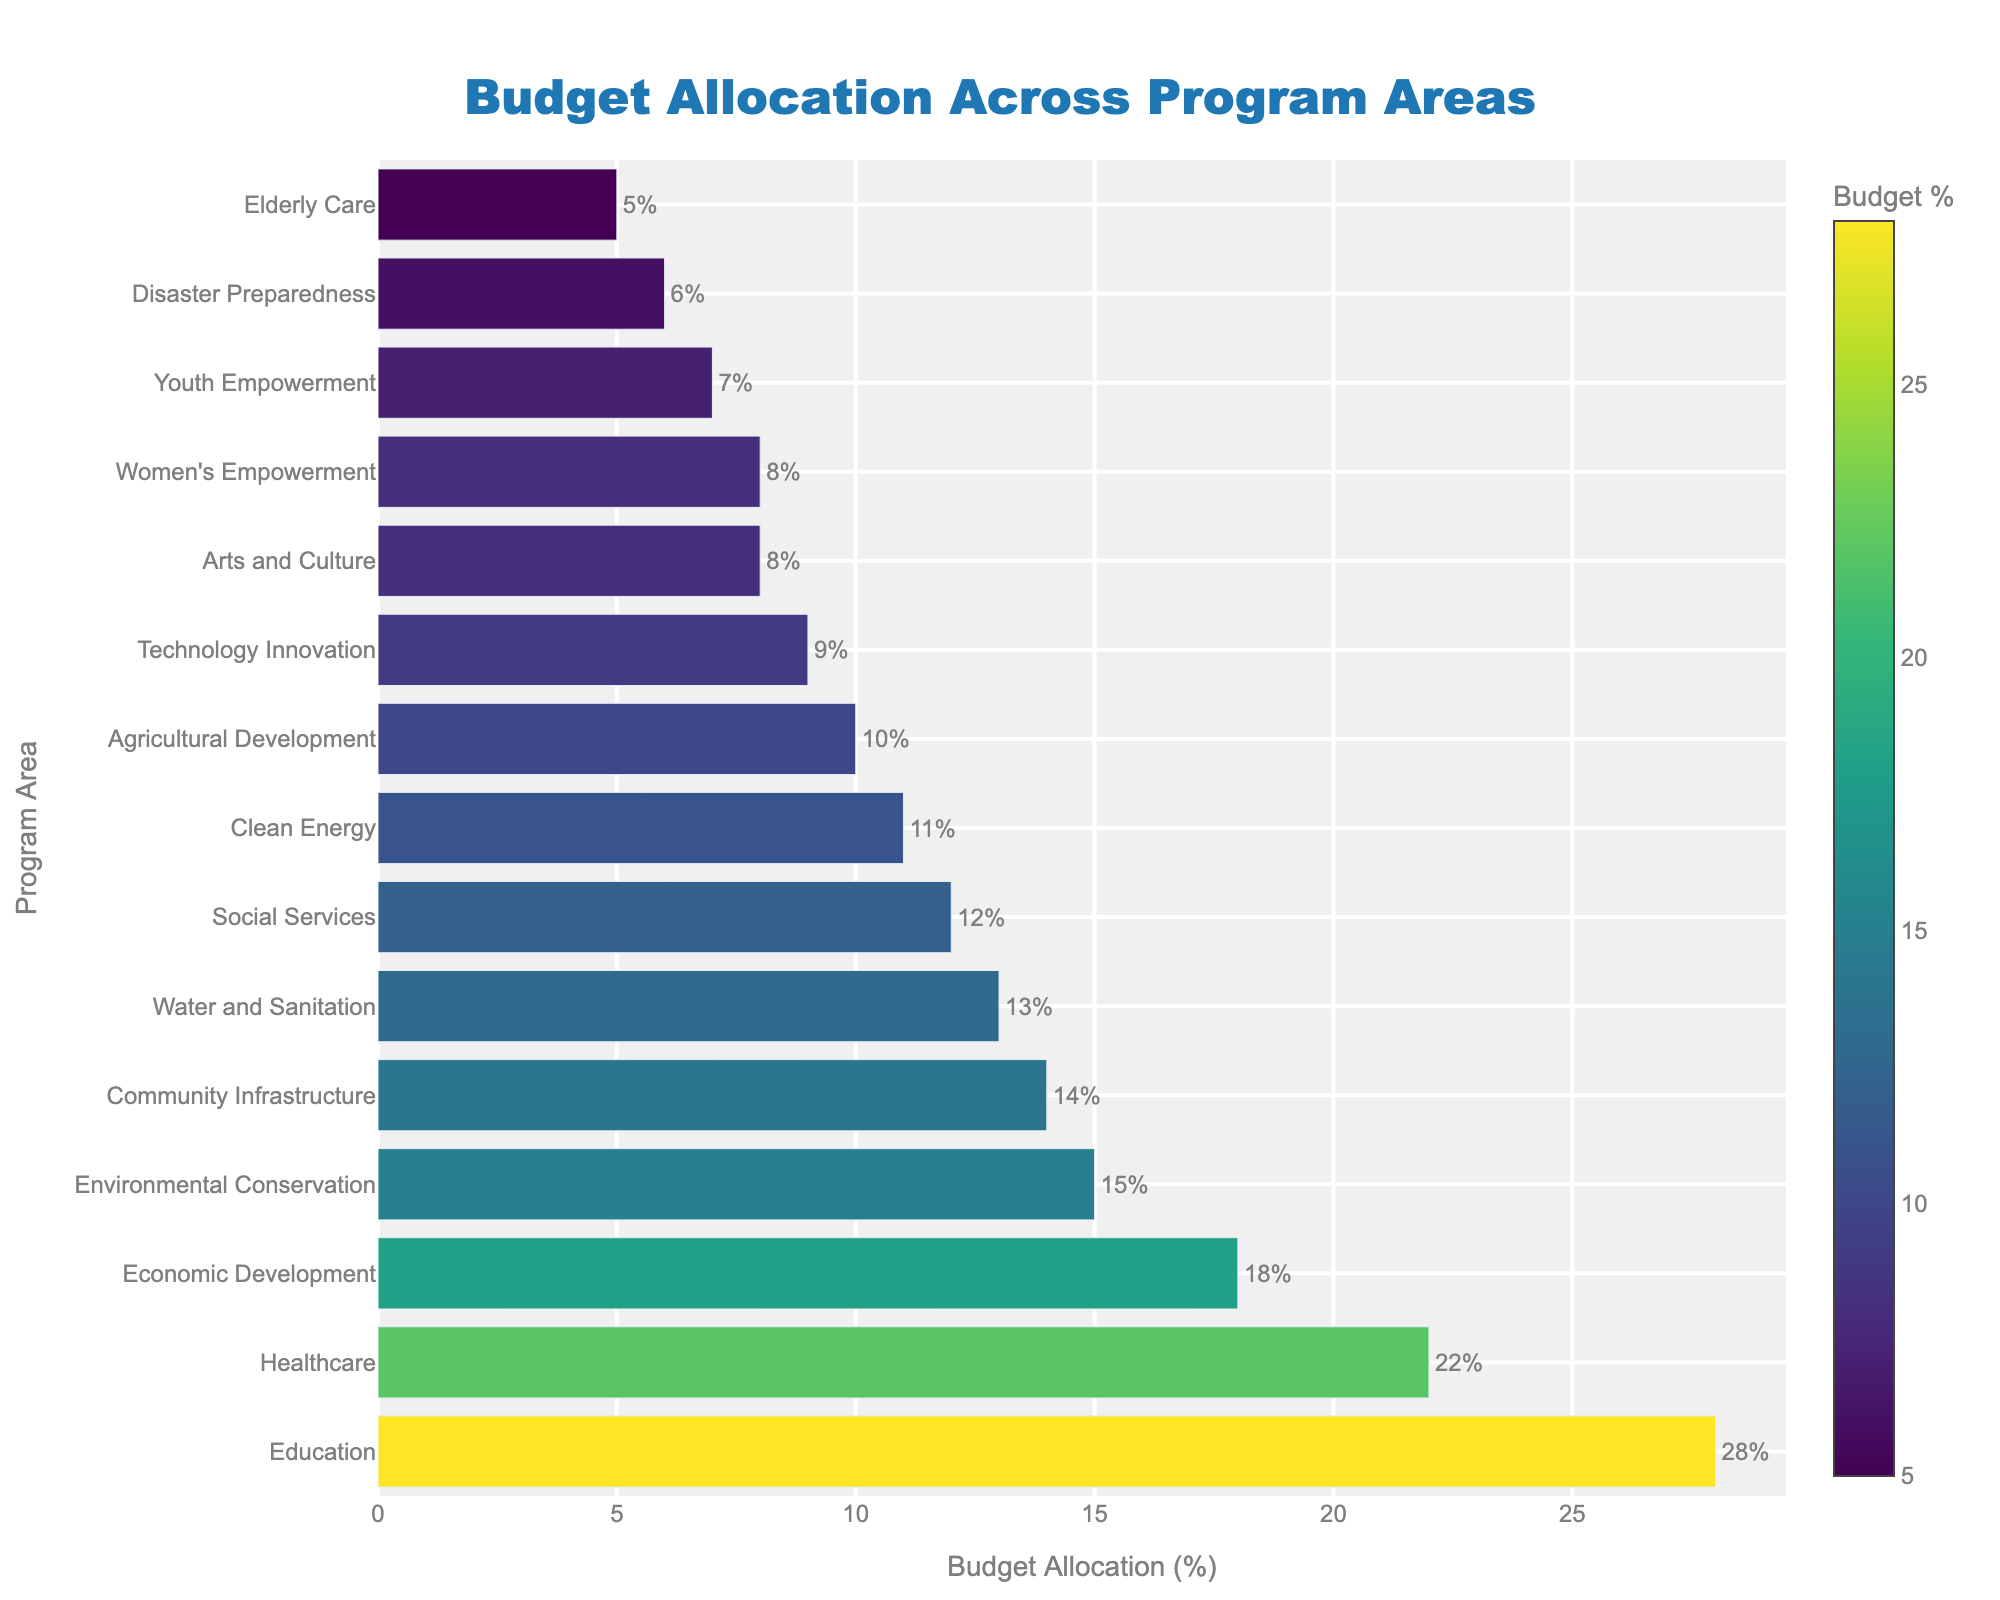What's the program area with the highest budget allocation percentage? The bar chart shows the program areas and their respective budget allocations. The longest bar represents Education, which has the highest percentage.
Answer: Education Which two program areas have the smallest budget allocation percentages combined? The smallest budget allocations are represented by the shortest bars. They are Disaster Preparedness (6%) and Elderly Care (5%). Summing them up gives 11%.
Answer: Disaster Preparedness and Elderly Care How does the budget allocation for Healthcare compare to Technology Innovation? The bar lengths for Healthcare and Technology Innovation can be compared. Healthcare has a longer bar with 22%, while Technology Innovation has a shorter bar with 9%. So, Healthcare has a higher allocation.
Answer: Healthcare has a higher allocation What is the combined budget allocation for Education, Healthcare, and Economic Development? The budget allocations for Education, Healthcare, and Economic Development are 28%, 22%, and 18%, respectively. Summing them up: 28 + 22 + 18 = 68%.
Answer: 68% Which program area has a higher budget allocation: Arts and Culture or Women's Empowerment? The bar for Arts and Culture has a budget allocation of 8%, and Women's Empowerment also has 8%. Both are equal.
Answer: Both are equal By how much does the budget allocation for Environmental Conservation exceed that of Youth Empowerment? The bar lengths show that Environmental Conservation has a budget allocation of 15%, while Youth Empowerment has 7%. The difference is calculated as 15 - 7 = 8%.
Answer: 8% What is the average budget allocation percentage of Social Services, Clean Energy, and Water and Sanitation? The budget allocations for Social Services, Clean Energy, and Water and Sanitation are 12%, 11%, and 13%, respectively. Summing them up: 12 + 11 + 13 = 36. The average is 36 / 3 = 12%.
Answer: 12% Which program area has the closest budget allocation percentage to Community Infrastructure? Community Infrastructure has a budget allocation of 14%. Closest budget allocation is Water and Sanitation with 13%.
Answer: Water and Sanitation 